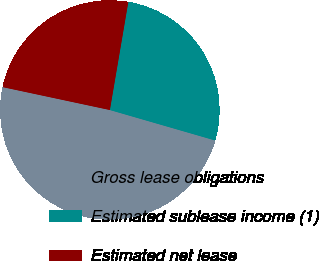<chart> <loc_0><loc_0><loc_500><loc_500><pie_chart><fcel>Gross lease obligations<fcel>Estimated sublease income (1)<fcel>Estimated net lease<nl><fcel>48.87%<fcel>26.79%<fcel>24.34%<nl></chart> 